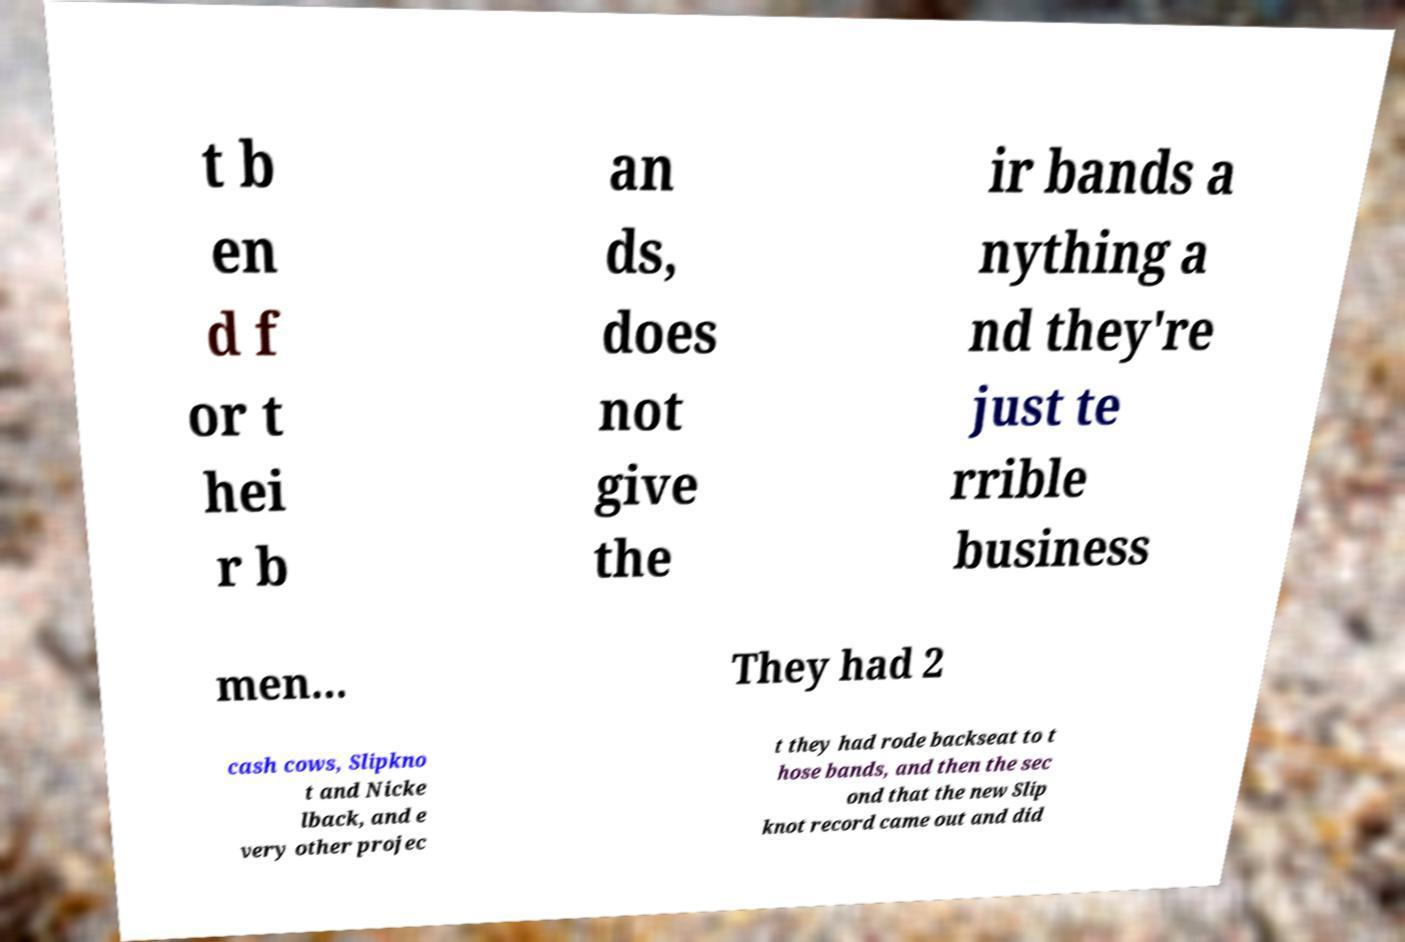Please identify and transcribe the text found in this image. t b en d f or t hei r b an ds, does not give the ir bands a nything a nd they're just te rrible business men... They had 2 cash cows, Slipkno t and Nicke lback, and e very other projec t they had rode backseat to t hose bands, and then the sec ond that the new Slip knot record came out and did 